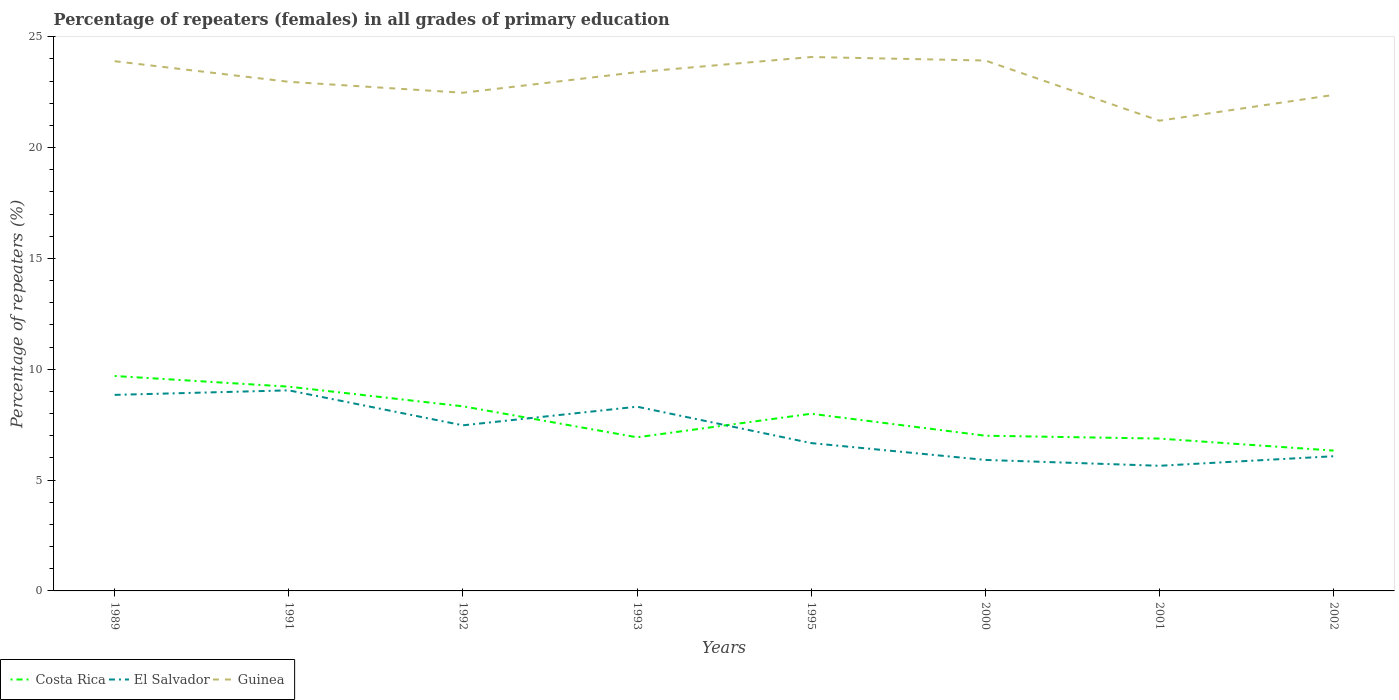Does the line corresponding to Costa Rica intersect with the line corresponding to El Salvador?
Ensure brevity in your answer.  Yes. Is the number of lines equal to the number of legend labels?
Give a very brief answer. Yes. Across all years, what is the maximum percentage of repeaters (females) in Guinea?
Give a very brief answer. 21.21. In which year was the percentage of repeaters (females) in Guinea maximum?
Provide a succinct answer. 2001. What is the total percentage of repeaters (females) in Guinea in the graph?
Your answer should be very brief. 1.55. What is the difference between the highest and the second highest percentage of repeaters (females) in El Salvador?
Make the answer very short. 3.4. What is the difference between the highest and the lowest percentage of repeaters (females) in El Salvador?
Provide a succinct answer. 4. Is the percentage of repeaters (females) in Guinea strictly greater than the percentage of repeaters (females) in El Salvador over the years?
Give a very brief answer. No. How many lines are there?
Provide a short and direct response. 3. What is the difference between two consecutive major ticks on the Y-axis?
Offer a very short reply. 5. Where does the legend appear in the graph?
Your answer should be very brief. Bottom left. How many legend labels are there?
Your answer should be compact. 3. What is the title of the graph?
Your answer should be very brief. Percentage of repeaters (females) in all grades of primary education. Does "Japan" appear as one of the legend labels in the graph?
Keep it short and to the point. No. What is the label or title of the Y-axis?
Keep it short and to the point. Percentage of repeaters (%). What is the Percentage of repeaters (%) in Costa Rica in 1989?
Provide a short and direct response. 9.7. What is the Percentage of repeaters (%) of El Salvador in 1989?
Your response must be concise. 8.84. What is the Percentage of repeaters (%) in Guinea in 1989?
Offer a very short reply. 23.9. What is the Percentage of repeaters (%) of Costa Rica in 1991?
Ensure brevity in your answer.  9.21. What is the Percentage of repeaters (%) in El Salvador in 1991?
Provide a short and direct response. 9.05. What is the Percentage of repeaters (%) of Guinea in 1991?
Make the answer very short. 22.97. What is the Percentage of repeaters (%) of Costa Rica in 1992?
Offer a terse response. 8.33. What is the Percentage of repeaters (%) in El Salvador in 1992?
Offer a very short reply. 7.47. What is the Percentage of repeaters (%) in Guinea in 1992?
Give a very brief answer. 22.47. What is the Percentage of repeaters (%) of Costa Rica in 1993?
Give a very brief answer. 6.93. What is the Percentage of repeaters (%) of El Salvador in 1993?
Offer a terse response. 8.31. What is the Percentage of repeaters (%) in Guinea in 1993?
Offer a very short reply. 23.4. What is the Percentage of repeaters (%) in Costa Rica in 1995?
Keep it short and to the point. 7.99. What is the Percentage of repeaters (%) of El Salvador in 1995?
Your answer should be compact. 6.67. What is the Percentage of repeaters (%) of Guinea in 1995?
Make the answer very short. 24.08. What is the Percentage of repeaters (%) of Costa Rica in 2000?
Provide a short and direct response. 7. What is the Percentage of repeaters (%) of El Salvador in 2000?
Give a very brief answer. 5.91. What is the Percentage of repeaters (%) in Guinea in 2000?
Offer a very short reply. 23.93. What is the Percentage of repeaters (%) of Costa Rica in 2001?
Provide a succinct answer. 6.87. What is the Percentage of repeaters (%) in El Salvador in 2001?
Provide a short and direct response. 5.65. What is the Percentage of repeaters (%) of Guinea in 2001?
Offer a terse response. 21.21. What is the Percentage of repeaters (%) in Costa Rica in 2002?
Offer a terse response. 6.33. What is the Percentage of repeaters (%) of El Salvador in 2002?
Provide a short and direct response. 6.08. What is the Percentage of repeaters (%) in Guinea in 2002?
Your answer should be very brief. 22.38. Across all years, what is the maximum Percentage of repeaters (%) in Costa Rica?
Provide a succinct answer. 9.7. Across all years, what is the maximum Percentage of repeaters (%) of El Salvador?
Ensure brevity in your answer.  9.05. Across all years, what is the maximum Percentage of repeaters (%) in Guinea?
Make the answer very short. 24.08. Across all years, what is the minimum Percentage of repeaters (%) in Costa Rica?
Your answer should be compact. 6.33. Across all years, what is the minimum Percentage of repeaters (%) in El Salvador?
Ensure brevity in your answer.  5.65. Across all years, what is the minimum Percentage of repeaters (%) in Guinea?
Offer a terse response. 21.21. What is the total Percentage of repeaters (%) in Costa Rica in the graph?
Ensure brevity in your answer.  62.36. What is the total Percentage of repeaters (%) of El Salvador in the graph?
Offer a very short reply. 57.97. What is the total Percentage of repeaters (%) of Guinea in the graph?
Provide a succinct answer. 184.33. What is the difference between the Percentage of repeaters (%) in Costa Rica in 1989 and that in 1991?
Give a very brief answer. 0.48. What is the difference between the Percentage of repeaters (%) in El Salvador in 1989 and that in 1991?
Give a very brief answer. -0.2. What is the difference between the Percentage of repeaters (%) of Guinea in 1989 and that in 1991?
Provide a succinct answer. 0.93. What is the difference between the Percentage of repeaters (%) of Costa Rica in 1989 and that in 1992?
Provide a succinct answer. 1.37. What is the difference between the Percentage of repeaters (%) in El Salvador in 1989 and that in 1992?
Provide a short and direct response. 1.37. What is the difference between the Percentage of repeaters (%) in Guinea in 1989 and that in 1992?
Your answer should be compact. 1.42. What is the difference between the Percentage of repeaters (%) of Costa Rica in 1989 and that in 1993?
Provide a succinct answer. 2.77. What is the difference between the Percentage of repeaters (%) in El Salvador in 1989 and that in 1993?
Your answer should be very brief. 0.53. What is the difference between the Percentage of repeaters (%) of Guinea in 1989 and that in 1993?
Provide a succinct answer. 0.49. What is the difference between the Percentage of repeaters (%) of Costa Rica in 1989 and that in 1995?
Keep it short and to the point. 1.7. What is the difference between the Percentage of repeaters (%) in El Salvador in 1989 and that in 1995?
Keep it short and to the point. 2.17. What is the difference between the Percentage of repeaters (%) of Guinea in 1989 and that in 1995?
Provide a short and direct response. -0.19. What is the difference between the Percentage of repeaters (%) in Costa Rica in 1989 and that in 2000?
Give a very brief answer. 2.69. What is the difference between the Percentage of repeaters (%) in El Salvador in 1989 and that in 2000?
Your answer should be very brief. 2.93. What is the difference between the Percentage of repeaters (%) in Guinea in 1989 and that in 2000?
Offer a terse response. -0.03. What is the difference between the Percentage of repeaters (%) of Costa Rica in 1989 and that in 2001?
Offer a very short reply. 2.82. What is the difference between the Percentage of repeaters (%) in El Salvador in 1989 and that in 2001?
Your answer should be compact. 3.2. What is the difference between the Percentage of repeaters (%) in Guinea in 1989 and that in 2001?
Provide a succinct answer. 2.69. What is the difference between the Percentage of repeaters (%) of Costa Rica in 1989 and that in 2002?
Your response must be concise. 3.36. What is the difference between the Percentage of repeaters (%) in El Salvador in 1989 and that in 2002?
Offer a terse response. 2.77. What is the difference between the Percentage of repeaters (%) of Guinea in 1989 and that in 2002?
Make the answer very short. 1.52. What is the difference between the Percentage of repeaters (%) in Costa Rica in 1991 and that in 1992?
Offer a terse response. 0.89. What is the difference between the Percentage of repeaters (%) in El Salvador in 1991 and that in 1992?
Your answer should be compact. 1.58. What is the difference between the Percentage of repeaters (%) of Guinea in 1991 and that in 1992?
Your response must be concise. 0.49. What is the difference between the Percentage of repeaters (%) in Costa Rica in 1991 and that in 1993?
Offer a very short reply. 2.28. What is the difference between the Percentage of repeaters (%) of El Salvador in 1991 and that in 1993?
Provide a succinct answer. 0.74. What is the difference between the Percentage of repeaters (%) of Guinea in 1991 and that in 1993?
Offer a very short reply. -0.44. What is the difference between the Percentage of repeaters (%) in Costa Rica in 1991 and that in 1995?
Provide a succinct answer. 1.22. What is the difference between the Percentage of repeaters (%) in El Salvador in 1991 and that in 1995?
Provide a short and direct response. 2.38. What is the difference between the Percentage of repeaters (%) of Guinea in 1991 and that in 1995?
Ensure brevity in your answer.  -1.12. What is the difference between the Percentage of repeaters (%) of Costa Rica in 1991 and that in 2000?
Offer a very short reply. 2.21. What is the difference between the Percentage of repeaters (%) in El Salvador in 1991 and that in 2000?
Keep it short and to the point. 3.14. What is the difference between the Percentage of repeaters (%) in Guinea in 1991 and that in 2000?
Your answer should be very brief. -0.96. What is the difference between the Percentage of repeaters (%) of Costa Rica in 1991 and that in 2001?
Your answer should be compact. 2.34. What is the difference between the Percentage of repeaters (%) of El Salvador in 1991 and that in 2001?
Offer a very short reply. 3.4. What is the difference between the Percentage of repeaters (%) in Guinea in 1991 and that in 2001?
Keep it short and to the point. 1.76. What is the difference between the Percentage of repeaters (%) in Costa Rica in 1991 and that in 2002?
Offer a very short reply. 2.88. What is the difference between the Percentage of repeaters (%) of El Salvador in 1991 and that in 2002?
Provide a short and direct response. 2.97. What is the difference between the Percentage of repeaters (%) in Guinea in 1991 and that in 2002?
Your response must be concise. 0.59. What is the difference between the Percentage of repeaters (%) in Costa Rica in 1992 and that in 1993?
Your response must be concise. 1.4. What is the difference between the Percentage of repeaters (%) of El Salvador in 1992 and that in 1993?
Your answer should be very brief. -0.84. What is the difference between the Percentage of repeaters (%) in Guinea in 1992 and that in 1993?
Your answer should be compact. -0.93. What is the difference between the Percentage of repeaters (%) in Costa Rica in 1992 and that in 1995?
Your answer should be compact. 0.34. What is the difference between the Percentage of repeaters (%) in El Salvador in 1992 and that in 1995?
Provide a short and direct response. 0.8. What is the difference between the Percentage of repeaters (%) of Guinea in 1992 and that in 1995?
Keep it short and to the point. -1.61. What is the difference between the Percentage of repeaters (%) in Costa Rica in 1992 and that in 2000?
Offer a terse response. 1.33. What is the difference between the Percentage of repeaters (%) of El Salvador in 1992 and that in 2000?
Your answer should be compact. 1.56. What is the difference between the Percentage of repeaters (%) of Guinea in 1992 and that in 2000?
Give a very brief answer. -1.45. What is the difference between the Percentage of repeaters (%) in Costa Rica in 1992 and that in 2001?
Provide a short and direct response. 1.46. What is the difference between the Percentage of repeaters (%) of El Salvador in 1992 and that in 2001?
Your answer should be very brief. 1.82. What is the difference between the Percentage of repeaters (%) of Guinea in 1992 and that in 2001?
Offer a very short reply. 1.26. What is the difference between the Percentage of repeaters (%) in Costa Rica in 1992 and that in 2002?
Give a very brief answer. 2. What is the difference between the Percentage of repeaters (%) in El Salvador in 1992 and that in 2002?
Give a very brief answer. 1.39. What is the difference between the Percentage of repeaters (%) of Guinea in 1992 and that in 2002?
Provide a succinct answer. 0.1. What is the difference between the Percentage of repeaters (%) in Costa Rica in 1993 and that in 1995?
Ensure brevity in your answer.  -1.06. What is the difference between the Percentage of repeaters (%) of El Salvador in 1993 and that in 1995?
Your answer should be compact. 1.64. What is the difference between the Percentage of repeaters (%) in Guinea in 1993 and that in 1995?
Offer a terse response. -0.68. What is the difference between the Percentage of repeaters (%) in Costa Rica in 1993 and that in 2000?
Make the answer very short. -0.07. What is the difference between the Percentage of repeaters (%) in El Salvador in 1993 and that in 2000?
Provide a succinct answer. 2.4. What is the difference between the Percentage of repeaters (%) in Guinea in 1993 and that in 2000?
Ensure brevity in your answer.  -0.53. What is the difference between the Percentage of repeaters (%) in Costa Rica in 1993 and that in 2001?
Make the answer very short. 0.06. What is the difference between the Percentage of repeaters (%) of El Salvador in 1993 and that in 2001?
Keep it short and to the point. 2.67. What is the difference between the Percentage of repeaters (%) in Guinea in 1993 and that in 2001?
Your answer should be compact. 2.19. What is the difference between the Percentage of repeaters (%) in Costa Rica in 1993 and that in 2002?
Your response must be concise. 0.6. What is the difference between the Percentage of repeaters (%) of El Salvador in 1993 and that in 2002?
Give a very brief answer. 2.23. What is the difference between the Percentage of repeaters (%) in Guinea in 1993 and that in 2002?
Your response must be concise. 1.03. What is the difference between the Percentage of repeaters (%) in Costa Rica in 1995 and that in 2000?
Offer a terse response. 0.99. What is the difference between the Percentage of repeaters (%) in El Salvador in 1995 and that in 2000?
Provide a short and direct response. 0.76. What is the difference between the Percentage of repeaters (%) in Guinea in 1995 and that in 2000?
Ensure brevity in your answer.  0.16. What is the difference between the Percentage of repeaters (%) in Costa Rica in 1995 and that in 2001?
Your answer should be very brief. 1.12. What is the difference between the Percentage of repeaters (%) of El Salvador in 1995 and that in 2001?
Your answer should be very brief. 1.02. What is the difference between the Percentage of repeaters (%) in Guinea in 1995 and that in 2001?
Provide a short and direct response. 2.87. What is the difference between the Percentage of repeaters (%) of Costa Rica in 1995 and that in 2002?
Make the answer very short. 1.66. What is the difference between the Percentage of repeaters (%) in El Salvador in 1995 and that in 2002?
Your answer should be compact. 0.59. What is the difference between the Percentage of repeaters (%) in Guinea in 1995 and that in 2002?
Ensure brevity in your answer.  1.71. What is the difference between the Percentage of repeaters (%) of Costa Rica in 2000 and that in 2001?
Offer a very short reply. 0.13. What is the difference between the Percentage of repeaters (%) in El Salvador in 2000 and that in 2001?
Your response must be concise. 0.26. What is the difference between the Percentage of repeaters (%) in Guinea in 2000 and that in 2001?
Provide a succinct answer. 2.72. What is the difference between the Percentage of repeaters (%) of Costa Rica in 2000 and that in 2002?
Offer a terse response. 0.67. What is the difference between the Percentage of repeaters (%) in El Salvador in 2000 and that in 2002?
Your response must be concise. -0.17. What is the difference between the Percentage of repeaters (%) of Guinea in 2000 and that in 2002?
Your response must be concise. 1.55. What is the difference between the Percentage of repeaters (%) of Costa Rica in 2001 and that in 2002?
Keep it short and to the point. 0.54. What is the difference between the Percentage of repeaters (%) in El Salvador in 2001 and that in 2002?
Your response must be concise. -0.43. What is the difference between the Percentage of repeaters (%) in Guinea in 2001 and that in 2002?
Your answer should be very brief. -1.16. What is the difference between the Percentage of repeaters (%) in Costa Rica in 1989 and the Percentage of repeaters (%) in El Salvador in 1991?
Provide a succinct answer. 0.65. What is the difference between the Percentage of repeaters (%) of Costa Rica in 1989 and the Percentage of repeaters (%) of Guinea in 1991?
Keep it short and to the point. -13.27. What is the difference between the Percentage of repeaters (%) of El Salvador in 1989 and the Percentage of repeaters (%) of Guinea in 1991?
Keep it short and to the point. -14.12. What is the difference between the Percentage of repeaters (%) of Costa Rica in 1989 and the Percentage of repeaters (%) of El Salvador in 1992?
Your answer should be compact. 2.23. What is the difference between the Percentage of repeaters (%) in Costa Rica in 1989 and the Percentage of repeaters (%) in Guinea in 1992?
Ensure brevity in your answer.  -12.78. What is the difference between the Percentage of repeaters (%) in El Salvador in 1989 and the Percentage of repeaters (%) in Guinea in 1992?
Offer a terse response. -13.63. What is the difference between the Percentage of repeaters (%) in Costa Rica in 1989 and the Percentage of repeaters (%) in El Salvador in 1993?
Your answer should be very brief. 1.38. What is the difference between the Percentage of repeaters (%) in Costa Rica in 1989 and the Percentage of repeaters (%) in Guinea in 1993?
Your answer should be very brief. -13.71. What is the difference between the Percentage of repeaters (%) in El Salvador in 1989 and the Percentage of repeaters (%) in Guinea in 1993?
Ensure brevity in your answer.  -14.56. What is the difference between the Percentage of repeaters (%) of Costa Rica in 1989 and the Percentage of repeaters (%) of El Salvador in 1995?
Your response must be concise. 3.03. What is the difference between the Percentage of repeaters (%) of Costa Rica in 1989 and the Percentage of repeaters (%) of Guinea in 1995?
Your response must be concise. -14.39. What is the difference between the Percentage of repeaters (%) of El Salvador in 1989 and the Percentage of repeaters (%) of Guinea in 1995?
Your response must be concise. -15.24. What is the difference between the Percentage of repeaters (%) of Costa Rica in 1989 and the Percentage of repeaters (%) of El Salvador in 2000?
Provide a succinct answer. 3.79. What is the difference between the Percentage of repeaters (%) in Costa Rica in 1989 and the Percentage of repeaters (%) in Guinea in 2000?
Give a very brief answer. -14.23. What is the difference between the Percentage of repeaters (%) in El Salvador in 1989 and the Percentage of repeaters (%) in Guinea in 2000?
Your answer should be very brief. -15.08. What is the difference between the Percentage of repeaters (%) of Costa Rica in 1989 and the Percentage of repeaters (%) of El Salvador in 2001?
Your answer should be very brief. 4.05. What is the difference between the Percentage of repeaters (%) of Costa Rica in 1989 and the Percentage of repeaters (%) of Guinea in 2001?
Keep it short and to the point. -11.52. What is the difference between the Percentage of repeaters (%) in El Salvador in 1989 and the Percentage of repeaters (%) in Guinea in 2001?
Ensure brevity in your answer.  -12.37. What is the difference between the Percentage of repeaters (%) in Costa Rica in 1989 and the Percentage of repeaters (%) in El Salvador in 2002?
Give a very brief answer. 3.62. What is the difference between the Percentage of repeaters (%) of Costa Rica in 1989 and the Percentage of repeaters (%) of Guinea in 2002?
Your answer should be very brief. -12.68. What is the difference between the Percentage of repeaters (%) in El Salvador in 1989 and the Percentage of repeaters (%) in Guinea in 2002?
Keep it short and to the point. -13.53. What is the difference between the Percentage of repeaters (%) in Costa Rica in 1991 and the Percentage of repeaters (%) in El Salvador in 1992?
Provide a succinct answer. 1.74. What is the difference between the Percentage of repeaters (%) in Costa Rica in 1991 and the Percentage of repeaters (%) in Guinea in 1992?
Make the answer very short. -13.26. What is the difference between the Percentage of repeaters (%) of El Salvador in 1991 and the Percentage of repeaters (%) of Guinea in 1992?
Your response must be concise. -13.42. What is the difference between the Percentage of repeaters (%) of Costa Rica in 1991 and the Percentage of repeaters (%) of El Salvador in 1993?
Offer a terse response. 0.9. What is the difference between the Percentage of repeaters (%) of Costa Rica in 1991 and the Percentage of repeaters (%) of Guinea in 1993?
Provide a succinct answer. -14.19. What is the difference between the Percentage of repeaters (%) of El Salvador in 1991 and the Percentage of repeaters (%) of Guinea in 1993?
Offer a terse response. -14.35. What is the difference between the Percentage of repeaters (%) of Costa Rica in 1991 and the Percentage of repeaters (%) of El Salvador in 1995?
Provide a short and direct response. 2.55. What is the difference between the Percentage of repeaters (%) in Costa Rica in 1991 and the Percentage of repeaters (%) in Guinea in 1995?
Your response must be concise. -14.87. What is the difference between the Percentage of repeaters (%) of El Salvador in 1991 and the Percentage of repeaters (%) of Guinea in 1995?
Provide a short and direct response. -15.04. What is the difference between the Percentage of repeaters (%) in Costa Rica in 1991 and the Percentage of repeaters (%) in El Salvador in 2000?
Offer a terse response. 3.31. What is the difference between the Percentage of repeaters (%) in Costa Rica in 1991 and the Percentage of repeaters (%) in Guinea in 2000?
Provide a short and direct response. -14.71. What is the difference between the Percentage of repeaters (%) of El Salvador in 1991 and the Percentage of repeaters (%) of Guinea in 2000?
Keep it short and to the point. -14.88. What is the difference between the Percentage of repeaters (%) in Costa Rica in 1991 and the Percentage of repeaters (%) in El Salvador in 2001?
Provide a short and direct response. 3.57. What is the difference between the Percentage of repeaters (%) in Costa Rica in 1991 and the Percentage of repeaters (%) in Guinea in 2001?
Provide a short and direct response. -12. What is the difference between the Percentage of repeaters (%) in El Salvador in 1991 and the Percentage of repeaters (%) in Guinea in 2001?
Offer a terse response. -12.16. What is the difference between the Percentage of repeaters (%) in Costa Rica in 1991 and the Percentage of repeaters (%) in El Salvador in 2002?
Your answer should be compact. 3.14. What is the difference between the Percentage of repeaters (%) in Costa Rica in 1991 and the Percentage of repeaters (%) in Guinea in 2002?
Make the answer very short. -13.16. What is the difference between the Percentage of repeaters (%) in El Salvador in 1991 and the Percentage of repeaters (%) in Guinea in 2002?
Provide a short and direct response. -13.33. What is the difference between the Percentage of repeaters (%) in Costa Rica in 1992 and the Percentage of repeaters (%) in El Salvador in 1993?
Give a very brief answer. 0.02. What is the difference between the Percentage of repeaters (%) of Costa Rica in 1992 and the Percentage of repeaters (%) of Guinea in 1993?
Give a very brief answer. -15.07. What is the difference between the Percentage of repeaters (%) in El Salvador in 1992 and the Percentage of repeaters (%) in Guinea in 1993?
Your answer should be very brief. -15.93. What is the difference between the Percentage of repeaters (%) of Costa Rica in 1992 and the Percentage of repeaters (%) of El Salvador in 1995?
Keep it short and to the point. 1.66. What is the difference between the Percentage of repeaters (%) in Costa Rica in 1992 and the Percentage of repeaters (%) in Guinea in 1995?
Your response must be concise. -15.76. What is the difference between the Percentage of repeaters (%) of El Salvador in 1992 and the Percentage of repeaters (%) of Guinea in 1995?
Offer a very short reply. -16.61. What is the difference between the Percentage of repeaters (%) in Costa Rica in 1992 and the Percentage of repeaters (%) in El Salvador in 2000?
Offer a terse response. 2.42. What is the difference between the Percentage of repeaters (%) in Costa Rica in 1992 and the Percentage of repeaters (%) in Guinea in 2000?
Provide a short and direct response. -15.6. What is the difference between the Percentage of repeaters (%) in El Salvador in 1992 and the Percentage of repeaters (%) in Guinea in 2000?
Provide a succinct answer. -16.46. What is the difference between the Percentage of repeaters (%) in Costa Rica in 1992 and the Percentage of repeaters (%) in El Salvador in 2001?
Provide a succinct answer. 2.68. What is the difference between the Percentage of repeaters (%) of Costa Rica in 1992 and the Percentage of repeaters (%) of Guinea in 2001?
Make the answer very short. -12.88. What is the difference between the Percentage of repeaters (%) of El Salvador in 1992 and the Percentage of repeaters (%) of Guinea in 2001?
Give a very brief answer. -13.74. What is the difference between the Percentage of repeaters (%) in Costa Rica in 1992 and the Percentage of repeaters (%) in El Salvador in 2002?
Provide a succinct answer. 2.25. What is the difference between the Percentage of repeaters (%) in Costa Rica in 1992 and the Percentage of repeaters (%) in Guinea in 2002?
Make the answer very short. -14.05. What is the difference between the Percentage of repeaters (%) of El Salvador in 1992 and the Percentage of repeaters (%) of Guinea in 2002?
Offer a terse response. -14.91. What is the difference between the Percentage of repeaters (%) of Costa Rica in 1993 and the Percentage of repeaters (%) of El Salvador in 1995?
Offer a terse response. 0.26. What is the difference between the Percentage of repeaters (%) in Costa Rica in 1993 and the Percentage of repeaters (%) in Guinea in 1995?
Offer a very short reply. -17.15. What is the difference between the Percentage of repeaters (%) of El Salvador in 1993 and the Percentage of repeaters (%) of Guinea in 1995?
Keep it short and to the point. -15.77. What is the difference between the Percentage of repeaters (%) in Costa Rica in 1993 and the Percentage of repeaters (%) in El Salvador in 2000?
Your answer should be compact. 1.02. What is the difference between the Percentage of repeaters (%) in Costa Rica in 1993 and the Percentage of repeaters (%) in Guinea in 2000?
Your response must be concise. -17. What is the difference between the Percentage of repeaters (%) of El Salvador in 1993 and the Percentage of repeaters (%) of Guinea in 2000?
Provide a short and direct response. -15.62. What is the difference between the Percentage of repeaters (%) of Costa Rica in 1993 and the Percentage of repeaters (%) of El Salvador in 2001?
Provide a short and direct response. 1.28. What is the difference between the Percentage of repeaters (%) in Costa Rica in 1993 and the Percentage of repeaters (%) in Guinea in 2001?
Your response must be concise. -14.28. What is the difference between the Percentage of repeaters (%) in El Salvador in 1993 and the Percentage of repeaters (%) in Guinea in 2001?
Offer a very short reply. -12.9. What is the difference between the Percentage of repeaters (%) in Costa Rica in 1993 and the Percentage of repeaters (%) in El Salvador in 2002?
Provide a short and direct response. 0.85. What is the difference between the Percentage of repeaters (%) in Costa Rica in 1993 and the Percentage of repeaters (%) in Guinea in 2002?
Keep it short and to the point. -15.45. What is the difference between the Percentage of repeaters (%) in El Salvador in 1993 and the Percentage of repeaters (%) in Guinea in 2002?
Offer a terse response. -14.06. What is the difference between the Percentage of repeaters (%) of Costa Rica in 1995 and the Percentage of repeaters (%) of El Salvador in 2000?
Make the answer very short. 2.08. What is the difference between the Percentage of repeaters (%) of Costa Rica in 1995 and the Percentage of repeaters (%) of Guinea in 2000?
Offer a terse response. -15.93. What is the difference between the Percentage of repeaters (%) in El Salvador in 1995 and the Percentage of repeaters (%) in Guinea in 2000?
Your answer should be very brief. -17.26. What is the difference between the Percentage of repeaters (%) in Costa Rica in 1995 and the Percentage of repeaters (%) in El Salvador in 2001?
Offer a terse response. 2.35. What is the difference between the Percentage of repeaters (%) in Costa Rica in 1995 and the Percentage of repeaters (%) in Guinea in 2001?
Make the answer very short. -13.22. What is the difference between the Percentage of repeaters (%) in El Salvador in 1995 and the Percentage of repeaters (%) in Guinea in 2001?
Your answer should be very brief. -14.54. What is the difference between the Percentage of repeaters (%) in Costa Rica in 1995 and the Percentage of repeaters (%) in El Salvador in 2002?
Give a very brief answer. 1.92. What is the difference between the Percentage of repeaters (%) of Costa Rica in 1995 and the Percentage of repeaters (%) of Guinea in 2002?
Offer a terse response. -14.38. What is the difference between the Percentage of repeaters (%) of El Salvador in 1995 and the Percentage of repeaters (%) of Guinea in 2002?
Give a very brief answer. -15.71. What is the difference between the Percentage of repeaters (%) in Costa Rica in 2000 and the Percentage of repeaters (%) in El Salvador in 2001?
Provide a short and direct response. 1.36. What is the difference between the Percentage of repeaters (%) of Costa Rica in 2000 and the Percentage of repeaters (%) of Guinea in 2001?
Give a very brief answer. -14.21. What is the difference between the Percentage of repeaters (%) in El Salvador in 2000 and the Percentage of repeaters (%) in Guinea in 2001?
Ensure brevity in your answer.  -15.3. What is the difference between the Percentage of repeaters (%) in Costa Rica in 2000 and the Percentage of repeaters (%) in El Salvador in 2002?
Offer a very short reply. 0.93. What is the difference between the Percentage of repeaters (%) of Costa Rica in 2000 and the Percentage of repeaters (%) of Guinea in 2002?
Your answer should be compact. -15.37. What is the difference between the Percentage of repeaters (%) of El Salvador in 2000 and the Percentage of repeaters (%) of Guinea in 2002?
Ensure brevity in your answer.  -16.47. What is the difference between the Percentage of repeaters (%) of Costa Rica in 2001 and the Percentage of repeaters (%) of El Salvador in 2002?
Your response must be concise. 0.8. What is the difference between the Percentage of repeaters (%) in Costa Rica in 2001 and the Percentage of repeaters (%) in Guinea in 2002?
Your answer should be very brief. -15.5. What is the difference between the Percentage of repeaters (%) of El Salvador in 2001 and the Percentage of repeaters (%) of Guinea in 2002?
Keep it short and to the point. -16.73. What is the average Percentage of repeaters (%) of Costa Rica per year?
Provide a short and direct response. 7.8. What is the average Percentage of repeaters (%) of El Salvador per year?
Keep it short and to the point. 7.25. What is the average Percentage of repeaters (%) of Guinea per year?
Ensure brevity in your answer.  23.04. In the year 1989, what is the difference between the Percentage of repeaters (%) in Costa Rica and Percentage of repeaters (%) in El Salvador?
Your answer should be compact. 0.85. In the year 1989, what is the difference between the Percentage of repeaters (%) of Costa Rica and Percentage of repeaters (%) of Guinea?
Give a very brief answer. -14.2. In the year 1989, what is the difference between the Percentage of repeaters (%) in El Salvador and Percentage of repeaters (%) in Guinea?
Ensure brevity in your answer.  -15.05. In the year 1991, what is the difference between the Percentage of repeaters (%) in Costa Rica and Percentage of repeaters (%) in El Salvador?
Provide a succinct answer. 0.17. In the year 1991, what is the difference between the Percentage of repeaters (%) in Costa Rica and Percentage of repeaters (%) in Guinea?
Provide a short and direct response. -13.75. In the year 1991, what is the difference between the Percentage of repeaters (%) of El Salvador and Percentage of repeaters (%) of Guinea?
Provide a succinct answer. -13.92. In the year 1992, what is the difference between the Percentage of repeaters (%) in Costa Rica and Percentage of repeaters (%) in El Salvador?
Provide a succinct answer. 0.86. In the year 1992, what is the difference between the Percentage of repeaters (%) in Costa Rica and Percentage of repeaters (%) in Guinea?
Provide a succinct answer. -14.14. In the year 1992, what is the difference between the Percentage of repeaters (%) in El Salvador and Percentage of repeaters (%) in Guinea?
Provide a succinct answer. -15. In the year 1993, what is the difference between the Percentage of repeaters (%) of Costa Rica and Percentage of repeaters (%) of El Salvador?
Keep it short and to the point. -1.38. In the year 1993, what is the difference between the Percentage of repeaters (%) of Costa Rica and Percentage of repeaters (%) of Guinea?
Ensure brevity in your answer.  -16.47. In the year 1993, what is the difference between the Percentage of repeaters (%) in El Salvador and Percentage of repeaters (%) in Guinea?
Your answer should be very brief. -15.09. In the year 1995, what is the difference between the Percentage of repeaters (%) of Costa Rica and Percentage of repeaters (%) of El Salvador?
Your answer should be very brief. 1.32. In the year 1995, what is the difference between the Percentage of repeaters (%) in Costa Rica and Percentage of repeaters (%) in Guinea?
Make the answer very short. -16.09. In the year 1995, what is the difference between the Percentage of repeaters (%) of El Salvador and Percentage of repeaters (%) of Guinea?
Offer a very short reply. -17.42. In the year 2000, what is the difference between the Percentage of repeaters (%) of Costa Rica and Percentage of repeaters (%) of El Salvador?
Give a very brief answer. 1.09. In the year 2000, what is the difference between the Percentage of repeaters (%) in Costa Rica and Percentage of repeaters (%) in Guinea?
Give a very brief answer. -16.92. In the year 2000, what is the difference between the Percentage of repeaters (%) of El Salvador and Percentage of repeaters (%) of Guinea?
Ensure brevity in your answer.  -18.02. In the year 2001, what is the difference between the Percentage of repeaters (%) in Costa Rica and Percentage of repeaters (%) in El Salvador?
Offer a very short reply. 1.23. In the year 2001, what is the difference between the Percentage of repeaters (%) of Costa Rica and Percentage of repeaters (%) of Guinea?
Offer a very short reply. -14.34. In the year 2001, what is the difference between the Percentage of repeaters (%) of El Salvador and Percentage of repeaters (%) of Guinea?
Offer a very short reply. -15.57. In the year 2002, what is the difference between the Percentage of repeaters (%) in Costa Rica and Percentage of repeaters (%) in El Salvador?
Your response must be concise. 0.25. In the year 2002, what is the difference between the Percentage of repeaters (%) in Costa Rica and Percentage of repeaters (%) in Guinea?
Your response must be concise. -16.04. In the year 2002, what is the difference between the Percentage of repeaters (%) of El Salvador and Percentage of repeaters (%) of Guinea?
Keep it short and to the point. -16.3. What is the ratio of the Percentage of repeaters (%) of Costa Rica in 1989 to that in 1991?
Keep it short and to the point. 1.05. What is the ratio of the Percentage of repeaters (%) of El Salvador in 1989 to that in 1991?
Your answer should be compact. 0.98. What is the ratio of the Percentage of repeaters (%) in Guinea in 1989 to that in 1991?
Make the answer very short. 1.04. What is the ratio of the Percentage of repeaters (%) of Costa Rica in 1989 to that in 1992?
Offer a very short reply. 1.16. What is the ratio of the Percentage of repeaters (%) in El Salvador in 1989 to that in 1992?
Provide a short and direct response. 1.18. What is the ratio of the Percentage of repeaters (%) of Guinea in 1989 to that in 1992?
Ensure brevity in your answer.  1.06. What is the ratio of the Percentage of repeaters (%) in Costa Rica in 1989 to that in 1993?
Ensure brevity in your answer.  1.4. What is the ratio of the Percentage of repeaters (%) of El Salvador in 1989 to that in 1993?
Offer a very short reply. 1.06. What is the ratio of the Percentage of repeaters (%) of Guinea in 1989 to that in 1993?
Ensure brevity in your answer.  1.02. What is the ratio of the Percentage of repeaters (%) of Costa Rica in 1989 to that in 1995?
Your answer should be very brief. 1.21. What is the ratio of the Percentage of repeaters (%) in El Salvador in 1989 to that in 1995?
Provide a short and direct response. 1.33. What is the ratio of the Percentage of repeaters (%) of Costa Rica in 1989 to that in 2000?
Make the answer very short. 1.38. What is the ratio of the Percentage of repeaters (%) of El Salvador in 1989 to that in 2000?
Give a very brief answer. 1.5. What is the ratio of the Percentage of repeaters (%) of Guinea in 1989 to that in 2000?
Give a very brief answer. 1. What is the ratio of the Percentage of repeaters (%) in Costa Rica in 1989 to that in 2001?
Provide a short and direct response. 1.41. What is the ratio of the Percentage of repeaters (%) of El Salvador in 1989 to that in 2001?
Provide a short and direct response. 1.57. What is the ratio of the Percentage of repeaters (%) of Guinea in 1989 to that in 2001?
Give a very brief answer. 1.13. What is the ratio of the Percentage of repeaters (%) in Costa Rica in 1989 to that in 2002?
Make the answer very short. 1.53. What is the ratio of the Percentage of repeaters (%) in El Salvador in 1989 to that in 2002?
Provide a succinct answer. 1.46. What is the ratio of the Percentage of repeaters (%) of Guinea in 1989 to that in 2002?
Give a very brief answer. 1.07. What is the ratio of the Percentage of repeaters (%) in Costa Rica in 1991 to that in 1992?
Give a very brief answer. 1.11. What is the ratio of the Percentage of repeaters (%) in El Salvador in 1991 to that in 1992?
Your answer should be very brief. 1.21. What is the ratio of the Percentage of repeaters (%) in Guinea in 1991 to that in 1992?
Your response must be concise. 1.02. What is the ratio of the Percentage of repeaters (%) of Costa Rica in 1991 to that in 1993?
Offer a terse response. 1.33. What is the ratio of the Percentage of repeaters (%) in El Salvador in 1991 to that in 1993?
Provide a succinct answer. 1.09. What is the ratio of the Percentage of repeaters (%) of Guinea in 1991 to that in 1993?
Ensure brevity in your answer.  0.98. What is the ratio of the Percentage of repeaters (%) in Costa Rica in 1991 to that in 1995?
Provide a short and direct response. 1.15. What is the ratio of the Percentage of repeaters (%) of El Salvador in 1991 to that in 1995?
Make the answer very short. 1.36. What is the ratio of the Percentage of repeaters (%) of Guinea in 1991 to that in 1995?
Provide a succinct answer. 0.95. What is the ratio of the Percentage of repeaters (%) in Costa Rica in 1991 to that in 2000?
Offer a very short reply. 1.32. What is the ratio of the Percentage of repeaters (%) of El Salvador in 1991 to that in 2000?
Offer a terse response. 1.53. What is the ratio of the Percentage of repeaters (%) in Guinea in 1991 to that in 2000?
Your response must be concise. 0.96. What is the ratio of the Percentage of repeaters (%) in Costa Rica in 1991 to that in 2001?
Your answer should be very brief. 1.34. What is the ratio of the Percentage of repeaters (%) in El Salvador in 1991 to that in 2001?
Offer a very short reply. 1.6. What is the ratio of the Percentage of repeaters (%) of Guinea in 1991 to that in 2001?
Keep it short and to the point. 1.08. What is the ratio of the Percentage of repeaters (%) of Costa Rica in 1991 to that in 2002?
Provide a succinct answer. 1.46. What is the ratio of the Percentage of repeaters (%) in El Salvador in 1991 to that in 2002?
Give a very brief answer. 1.49. What is the ratio of the Percentage of repeaters (%) of Guinea in 1991 to that in 2002?
Your answer should be compact. 1.03. What is the ratio of the Percentage of repeaters (%) of Costa Rica in 1992 to that in 1993?
Offer a terse response. 1.2. What is the ratio of the Percentage of repeaters (%) of El Salvador in 1992 to that in 1993?
Offer a terse response. 0.9. What is the ratio of the Percentage of repeaters (%) in Guinea in 1992 to that in 1993?
Your response must be concise. 0.96. What is the ratio of the Percentage of repeaters (%) of Costa Rica in 1992 to that in 1995?
Make the answer very short. 1.04. What is the ratio of the Percentage of repeaters (%) of El Salvador in 1992 to that in 1995?
Offer a very short reply. 1.12. What is the ratio of the Percentage of repeaters (%) in Guinea in 1992 to that in 1995?
Your answer should be very brief. 0.93. What is the ratio of the Percentage of repeaters (%) in Costa Rica in 1992 to that in 2000?
Your answer should be very brief. 1.19. What is the ratio of the Percentage of repeaters (%) of El Salvador in 1992 to that in 2000?
Your answer should be very brief. 1.26. What is the ratio of the Percentage of repeaters (%) of Guinea in 1992 to that in 2000?
Your answer should be compact. 0.94. What is the ratio of the Percentage of repeaters (%) in Costa Rica in 1992 to that in 2001?
Offer a very short reply. 1.21. What is the ratio of the Percentage of repeaters (%) in El Salvador in 1992 to that in 2001?
Your answer should be very brief. 1.32. What is the ratio of the Percentage of repeaters (%) of Guinea in 1992 to that in 2001?
Offer a very short reply. 1.06. What is the ratio of the Percentage of repeaters (%) of Costa Rica in 1992 to that in 2002?
Ensure brevity in your answer.  1.32. What is the ratio of the Percentage of repeaters (%) of El Salvador in 1992 to that in 2002?
Make the answer very short. 1.23. What is the ratio of the Percentage of repeaters (%) of Guinea in 1992 to that in 2002?
Provide a short and direct response. 1. What is the ratio of the Percentage of repeaters (%) of Costa Rica in 1993 to that in 1995?
Your response must be concise. 0.87. What is the ratio of the Percentage of repeaters (%) in El Salvador in 1993 to that in 1995?
Keep it short and to the point. 1.25. What is the ratio of the Percentage of repeaters (%) of Guinea in 1993 to that in 1995?
Provide a short and direct response. 0.97. What is the ratio of the Percentage of repeaters (%) in El Salvador in 1993 to that in 2000?
Offer a terse response. 1.41. What is the ratio of the Percentage of repeaters (%) in Guinea in 1993 to that in 2000?
Give a very brief answer. 0.98. What is the ratio of the Percentage of repeaters (%) of Costa Rica in 1993 to that in 2001?
Offer a very short reply. 1.01. What is the ratio of the Percentage of repeaters (%) of El Salvador in 1993 to that in 2001?
Your response must be concise. 1.47. What is the ratio of the Percentage of repeaters (%) in Guinea in 1993 to that in 2001?
Keep it short and to the point. 1.1. What is the ratio of the Percentage of repeaters (%) of Costa Rica in 1993 to that in 2002?
Ensure brevity in your answer.  1.09. What is the ratio of the Percentage of repeaters (%) of El Salvador in 1993 to that in 2002?
Provide a short and direct response. 1.37. What is the ratio of the Percentage of repeaters (%) of Guinea in 1993 to that in 2002?
Provide a short and direct response. 1.05. What is the ratio of the Percentage of repeaters (%) in Costa Rica in 1995 to that in 2000?
Provide a succinct answer. 1.14. What is the ratio of the Percentage of repeaters (%) of El Salvador in 1995 to that in 2000?
Offer a very short reply. 1.13. What is the ratio of the Percentage of repeaters (%) in Guinea in 1995 to that in 2000?
Offer a terse response. 1.01. What is the ratio of the Percentage of repeaters (%) of Costa Rica in 1995 to that in 2001?
Offer a very short reply. 1.16. What is the ratio of the Percentage of repeaters (%) of El Salvador in 1995 to that in 2001?
Your answer should be very brief. 1.18. What is the ratio of the Percentage of repeaters (%) of Guinea in 1995 to that in 2001?
Make the answer very short. 1.14. What is the ratio of the Percentage of repeaters (%) in Costa Rica in 1995 to that in 2002?
Your answer should be compact. 1.26. What is the ratio of the Percentage of repeaters (%) in El Salvador in 1995 to that in 2002?
Provide a succinct answer. 1.1. What is the ratio of the Percentage of repeaters (%) of Guinea in 1995 to that in 2002?
Give a very brief answer. 1.08. What is the ratio of the Percentage of repeaters (%) of Costa Rica in 2000 to that in 2001?
Your answer should be compact. 1.02. What is the ratio of the Percentage of repeaters (%) in El Salvador in 2000 to that in 2001?
Offer a very short reply. 1.05. What is the ratio of the Percentage of repeaters (%) of Guinea in 2000 to that in 2001?
Keep it short and to the point. 1.13. What is the ratio of the Percentage of repeaters (%) of Costa Rica in 2000 to that in 2002?
Provide a short and direct response. 1.11. What is the ratio of the Percentage of repeaters (%) of El Salvador in 2000 to that in 2002?
Keep it short and to the point. 0.97. What is the ratio of the Percentage of repeaters (%) of Guinea in 2000 to that in 2002?
Offer a very short reply. 1.07. What is the ratio of the Percentage of repeaters (%) in Costa Rica in 2001 to that in 2002?
Offer a very short reply. 1.09. What is the ratio of the Percentage of repeaters (%) of El Salvador in 2001 to that in 2002?
Your answer should be very brief. 0.93. What is the ratio of the Percentage of repeaters (%) of Guinea in 2001 to that in 2002?
Your response must be concise. 0.95. What is the difference between the highest and the second highest Percentage of repeaters (%) in Costa Rica?
Provide a succinct answer. 0.48. What is the difference between the highest and the second highest Percentage of repeaters (%) of El Salvador?
Your answer should be very brief. 0.2. What is the difference between the highest and the second highest Percentage of repeaters (%) in Guinea?
Provide a succinct answer. 0.16. What is the difference between the highest and the lowest Percentage of repeaters (%) in Costa Rica?
Provide a short and direct response. 3.36. What is the difference between the highest and the lowest Percentage of repeaters (%) of El Salvador?
Offer a terse response. 3.4. What is the difference between the highest and the lowest Percentage of repeaters (%) in Guinea?
Keep it short and to the point. 2.87. 